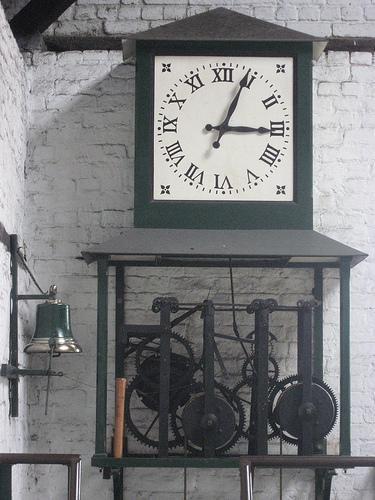How many clocks are there?
Give a very brief answer. 1. 